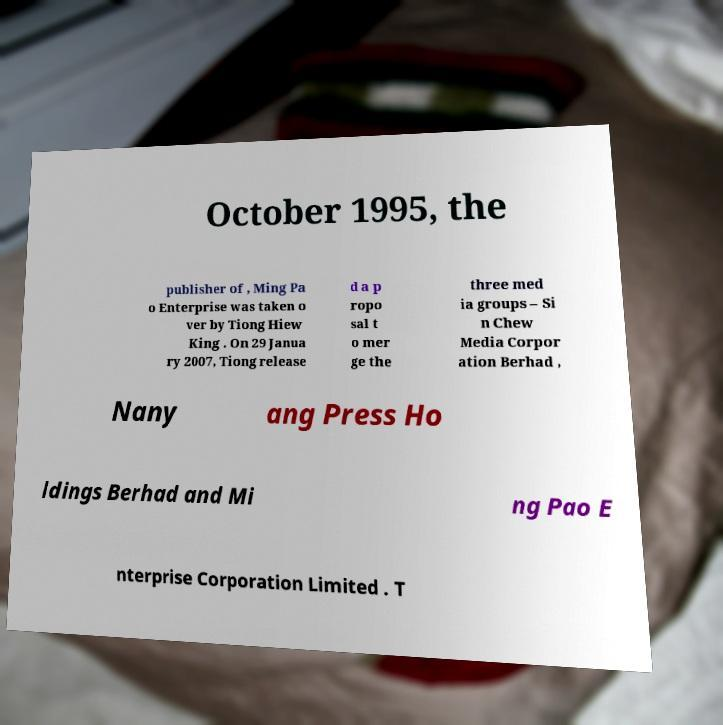Please identify and transcribe the text found in this image. October 1995, the publisher of , Ming Pa o Enterprise was taken o ver by Tiong Hiew King . On 29 Janua ry 2007, Tiong release d a p ropo sal t o mer ge the three med ia groups – Si n Chew Media Corpor ation Berhad , Nany ang Press Ho ldings Berhad and Mi ng Pao E nterprise Corporation Limited . T 